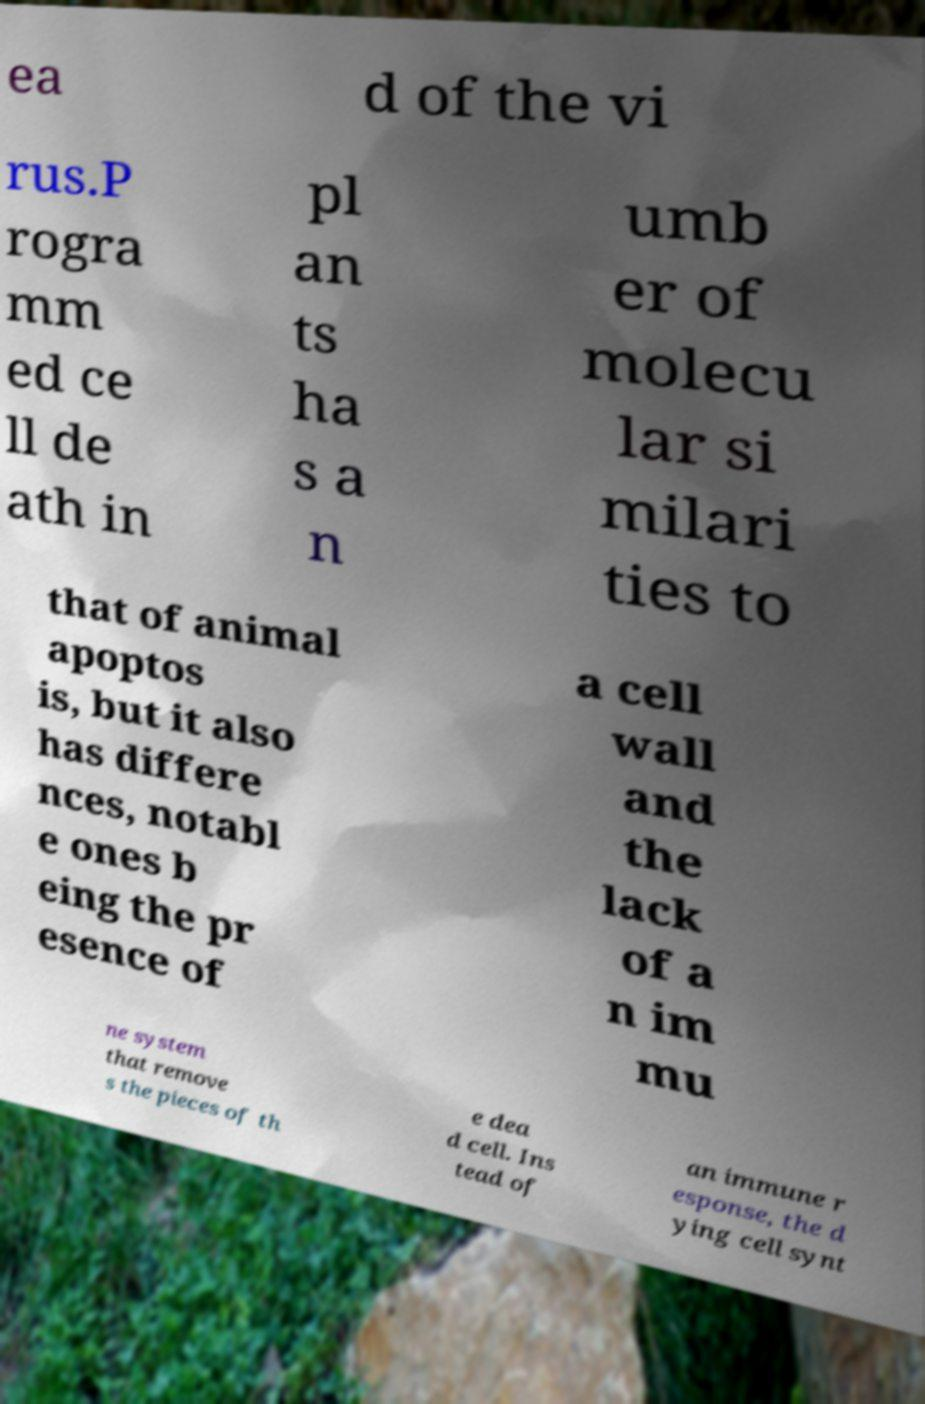What messages or text are displayed in this image? I need them in a readable, typed format. ea d of the vi rus.P rogra mm ed ce ll de ath in pl an ts ha s a n umb er of molecu lar si milari ties to that of animal apoptos is, but it also has differe nces, notabl e ones b eing the pr esence of a cell wall and the lack of a n im mu ne system that remove s the pieces of th e dea d cell. Ins tead of an immune r esponse, the d ying cell synt 